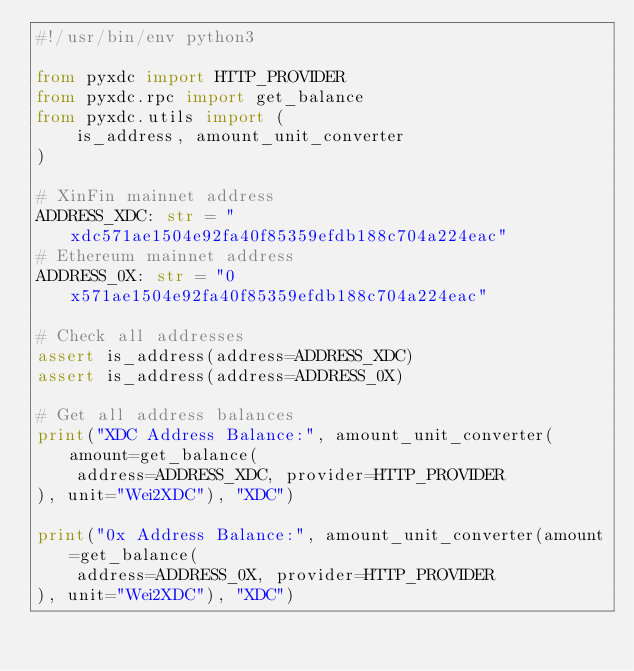<code> <loc_0><loc_0><loc_500><loc_500><_Python_>#!/usr/bin/env python3

from pyxdc import HTTP_PROVIDER
from pyxdc.rpc import get_balance
from pyxdc.utils import (
    is_address, amount_unit_converter
)

# XinFin mainnet address
ADDRESS_XDC: str = "xdc571ae1504e92fa40f85359efdb188c704a224eac"
# Ethereum mainnet address
ADDRESS_0X: str = "0x571ae1504e92fa40f85359efdb188c704a224eac"

# Check all addresses
assert is_address(address=ADDRESS_XDC)
assert is_address(address=ADDRESS_0X)

# Get all address balances
print("XDC Address Balance:", amount_unit_converter(amount=get_balance(
    address=ADDRESS_XDC, provider=HTTP_PROVIDER
), unit="Wei2XDC"), "XDC")

print("0x Address Balance:", amount_unit_converter(amount=get_balance(
    address=ADDRESS_0X, provider=HTTP_PROVIDER
), unit="Wei2XDC"), "XDC")
</code> 